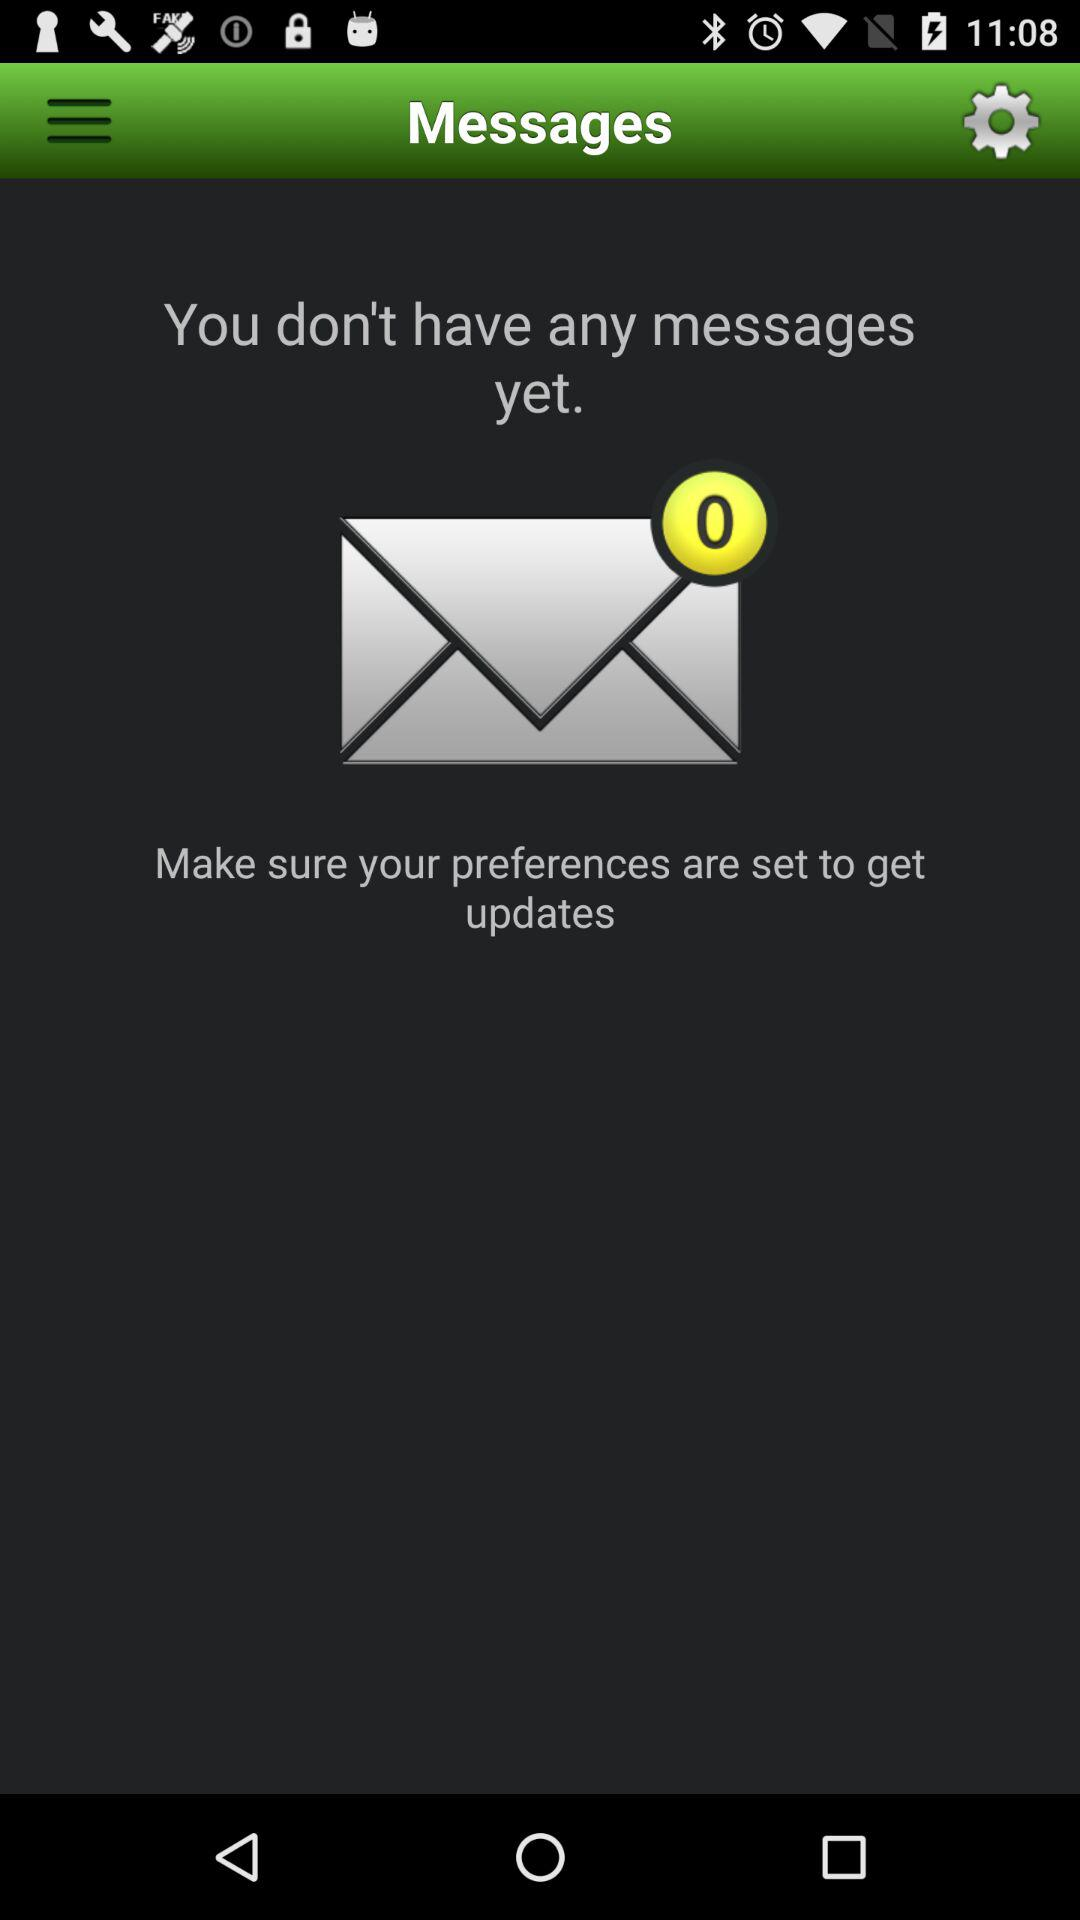How many messages do I have?
Answer the question using a single word or phrase. 0 